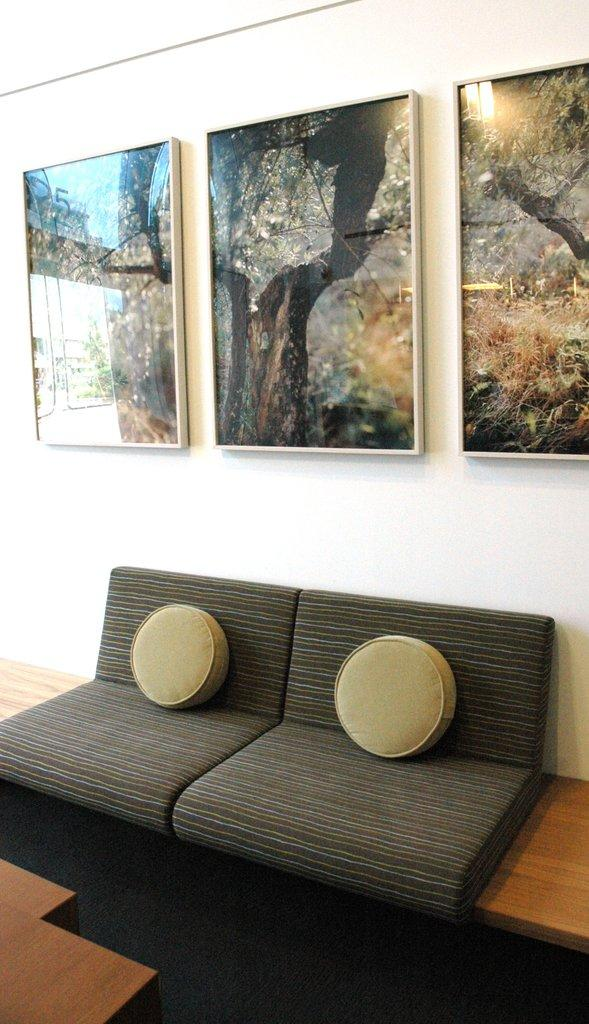What type of furniture is in the room? There is a sofa in the room. What is unique about the sofa's cushions? The sofa has 2 round cushions. What color is the wall behind the sofa? There is a white wall behind the sofa. What is depicted in the photo frames on the white wall? There are 3 photo frames of trees on the white wall. What direction is the person facing in the image? There is no person present in the image. What type of club is visible in the image? There is no club present in the image. 